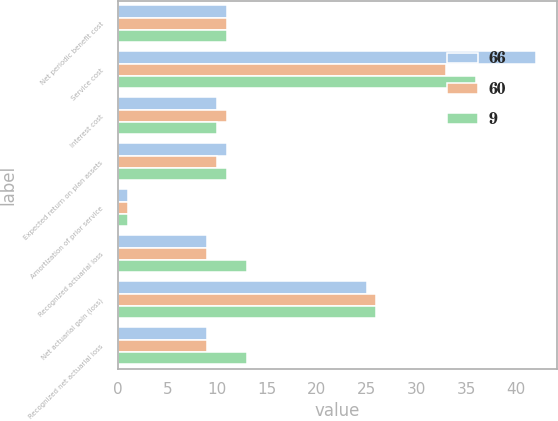Convert chart to OTSL. <chart><loc_0><loc_0><loc_500><loc_500><stacked_bar_chart><ecel><fcel>Net periodic benefit cost<fcel>Service cost<fcel>Interest cost<fcel>Expected return on plan assets<fcel>Amortization of prior service<fcel>Recognized actuarial loss<fcel>Net actuarial gain (loss)<fcel>Recognized net actuarial loss<nl><fcel>66<fcel>11<fcel>42<fcel>10<fcel>11<fcel>1<fcel>9<fcel>25<fcel>9<nl><fcel>60<fcel>11<fcel>33<fcel>11<fcel>10<fcel>1<fcel>9<fcel>26<fcel>9<nl><fcel>9<fcel>11<fcel>36<fcel>10<fcel>11<fcel>1<fcel>13<fcel>26<fcel>13<nl></chart> 